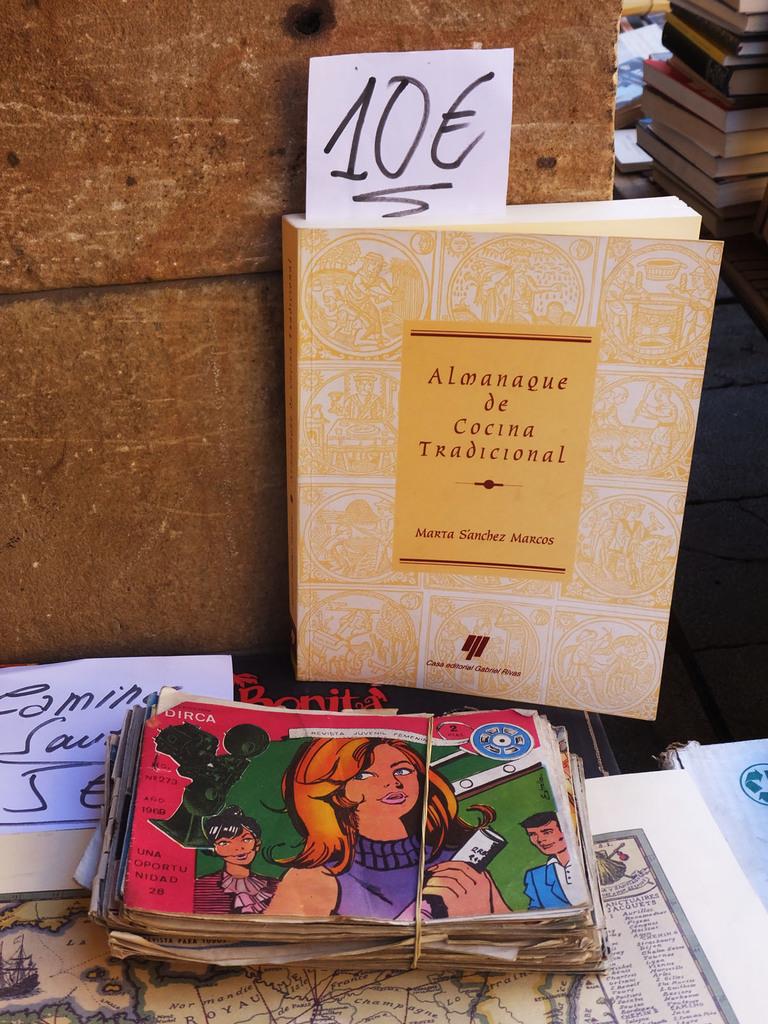How much is the book being sold for?
Keep it short and to the point. 10. What is the title of the book?
Give a very brief answer. Almanaque de cocina tradicional. 